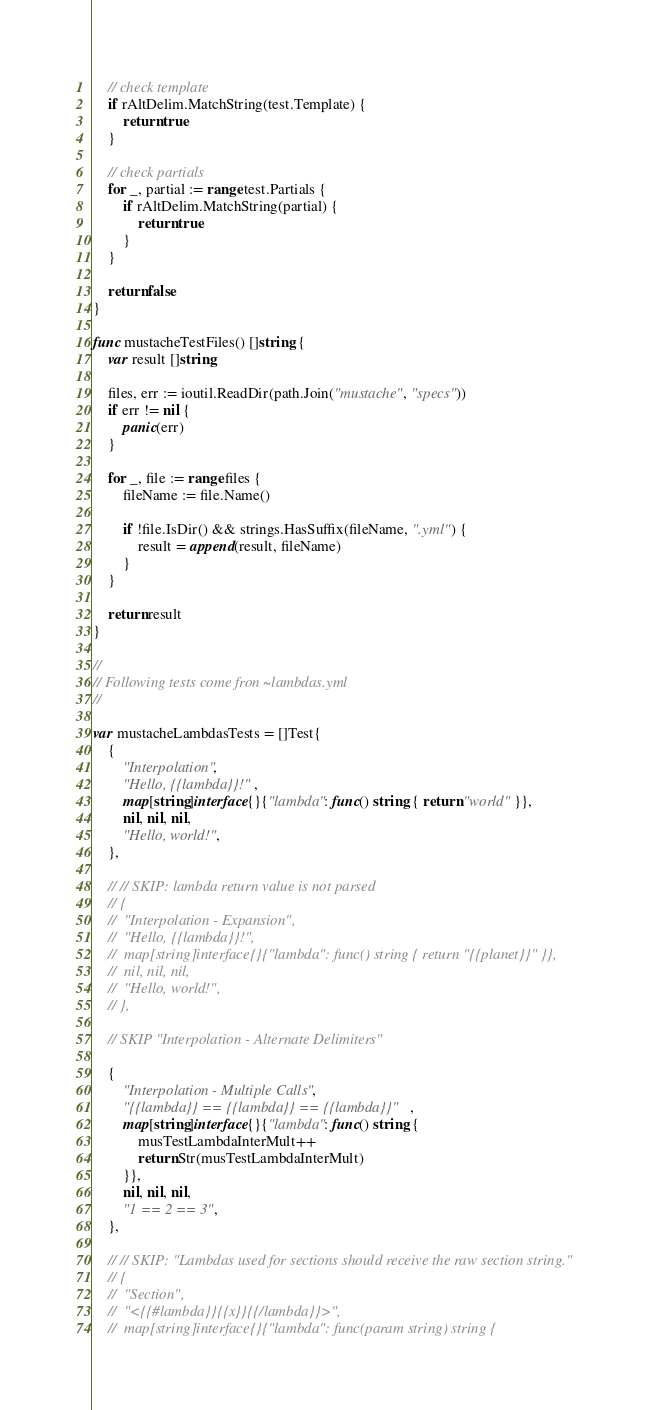<code> <loc_0><loc_0><loc_500><loc_500><_Go_>	// check template
	if rAltDelim.MatchString(test.Template) {
		return true
	}

	// check partials
	for _, partial := range test.Partials {
		if rAltDelim.MatchString(partial) {
			return true
		}
	}

	return false
}

func mustacheTestFiles() []string {
	var result []string

	files, err := ioutil.ReadDir(path.Join("mustache", "specs"))
	if err != nil {
		panic(err)
	}

	for _, file := range files {
		fileName := file.Name()

		if !file.IsDir() && strings.HasSuffix(fileName, ".yml") {
			result = append(result, fileName)
		}
	}

	return result
}

//
// Following tests come fron ~lambdas.yml
//

var mustacheLambdasTests = []Test{
	{
		"Interpolation",
		"Hello, {{lambda}}!",
		map[string]interface{}{"lambda": func() string { return "world" }},
		nil, nil, nil,
		"Hello, world!",
	},

	// // SKIP: lambda return value is not parsed
	// {
	// 	"Interpolation - Expansion",
	// 	"Hello, {{lambda}}!",
	// 	map[string]interface{}{"lambda": func() string { return "{{planet}}" }},
	// 	nil, nil, nil,
	// 	"Hello, world!",
	// },

	// SKIP "Interpolation - Alternate Delimiters"

	{
		"Interpolation - Multiple Calls",
		"{{lambda}} == {{lambda}} == {{lambda}}",
		map[string]interface{}{"lambda": func() string {
			musTestLambdaInterMult++
			return Str(musTestLambdaInterMult)
		}},
		nil, nil, nil,
		"1 == 2 == 3",
	},

	// // SKIP: "Lambdas used for sections should receive the raw section string."
	// {
	// 	"Section",
	// 	"<{{#lambda}}{{x}}{{/lambda}}>",
	// 	map[string]interface{}{"lambda": func(param string) string {</code> 